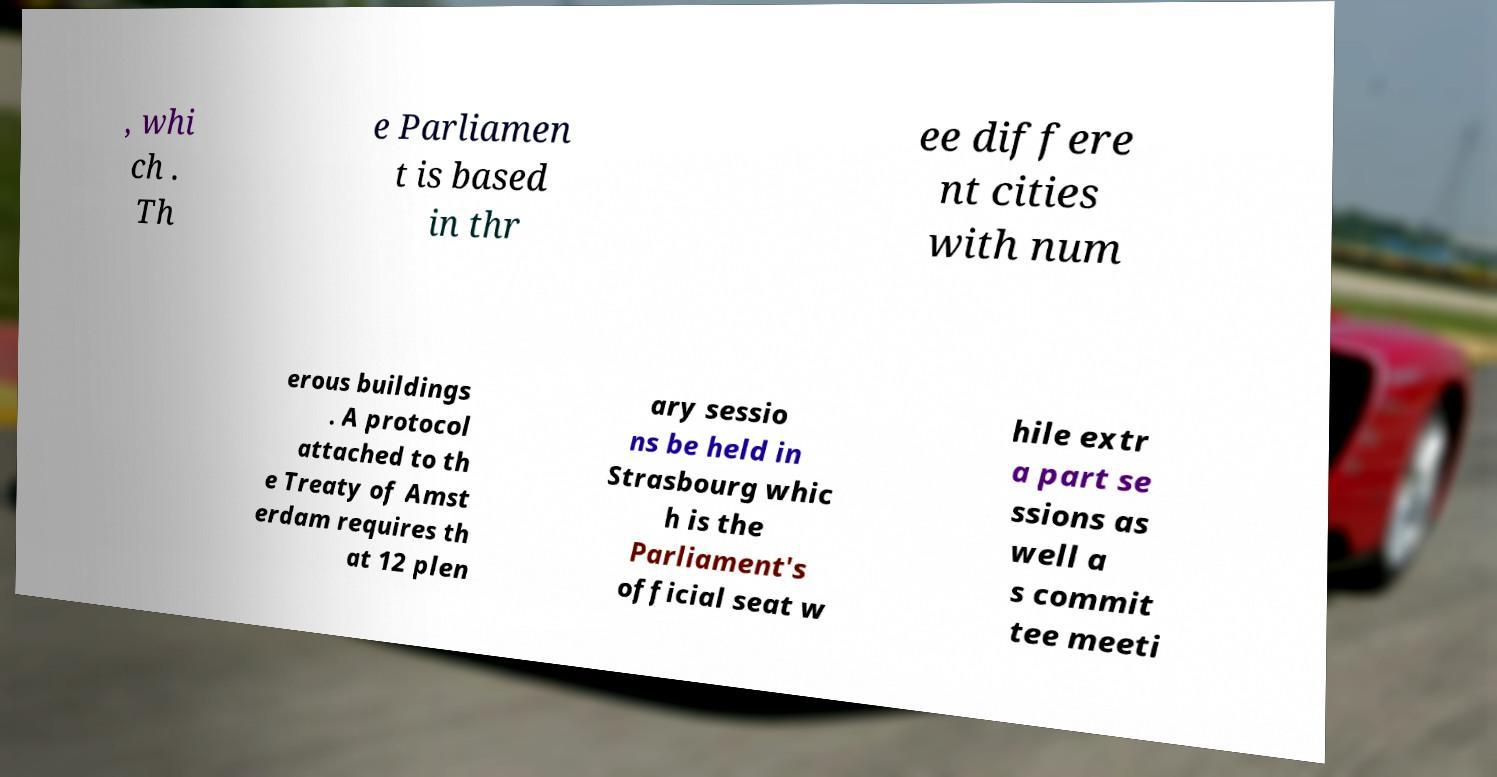Could you extract and type out the text from this image? , whi ch . Th e Parliamen t is based in thr ee differe nt cities with num erous buildings . A protocol attached to th e Treaty of Amst erdam requires th at 12 plen ary sessio ns be held in Strasbourg whic h is the Parliament's official seat w hile extr a part se ssions as well a s commit tee meeti 